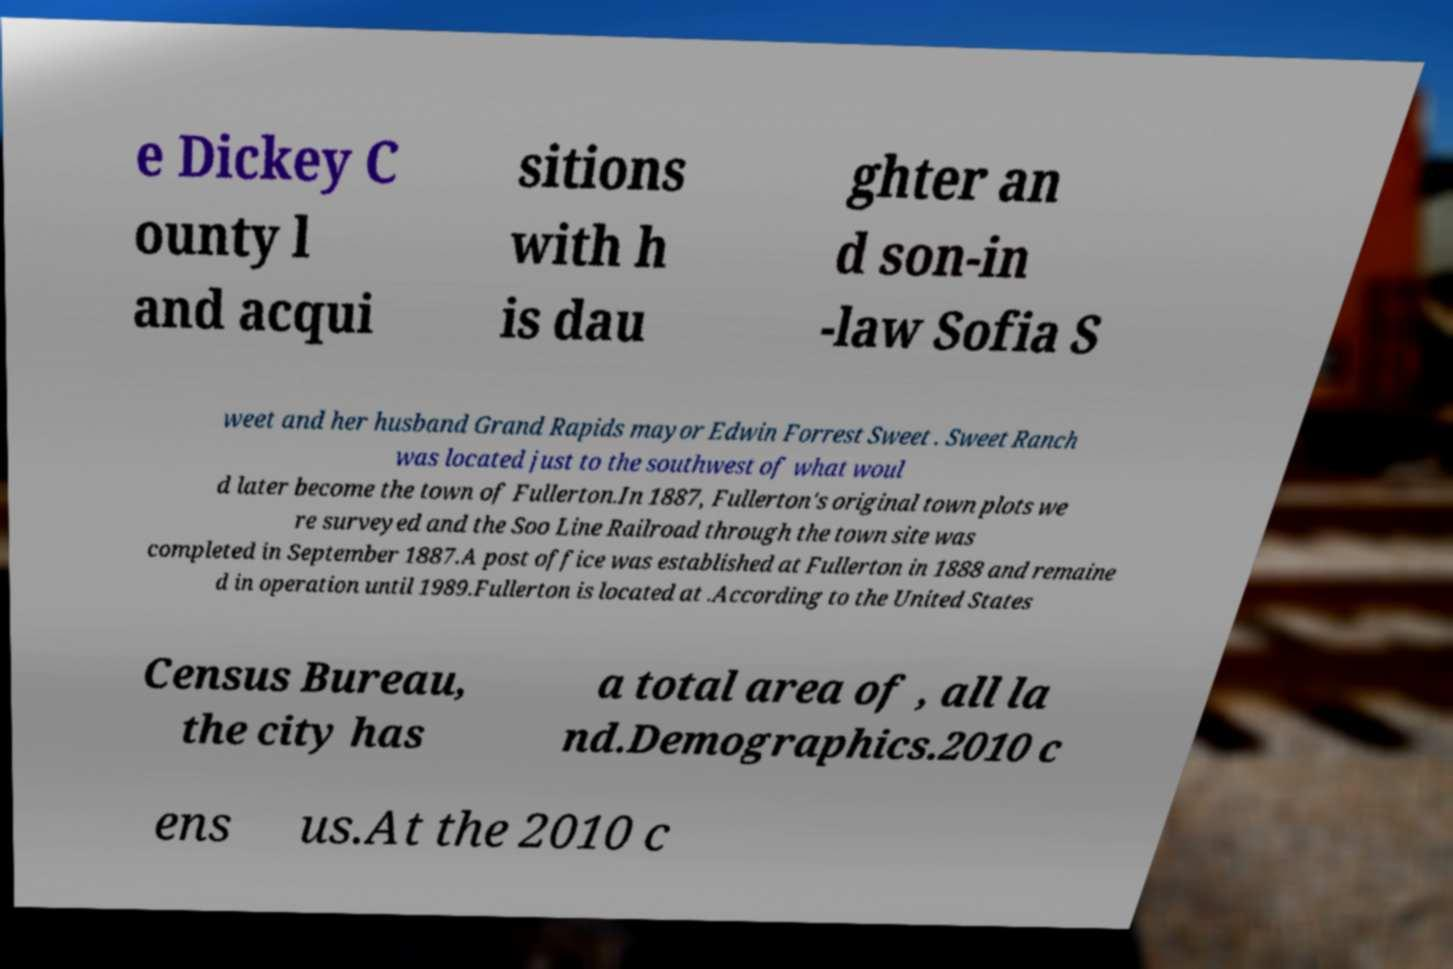Can you read and provide the text displayed in the image?This photo seems to have some interesting text. Can you extract and type it out for me? e Dickey C ounty l and acqui sitions with h is dau ghter an d son-in -law Sofia S weet and her husband Grand Rapids mayor Edwin Forrest Sweet . Sweet Ranch was located just to the southwest of what woul d later become the town of Fullerton.In 1887, Fullerton's original town plots we re surveyed and the Soo Line Railroad through the town site was completed in September 1887.A post office was established at Fullerton in 1888 and remaine d in operation until 1989.Fullerton is located at .According to the United States Census Bureau, the city has a total area of , all la nd.Demographics.2010 c ens us.At the 2010 c 